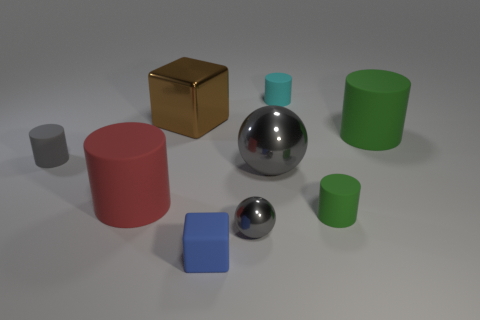The rubber cylinder that is the same color as the small shiny sphere is what size?
Offer a very short reply. Small. Is the brown metallic thing the same size as the cyan thing?
Make the answer very short. No. The gray object that is the same shape as the tiny green matte object is what size?
Your answer should be very brief. Small. There is a green thing behind the gray cylinder; does it have the same size as the block in front of the small gray cylinder?
Keep it short and to the point. No. Do the cyan object and the small gray thing that is to the right of the big red rubber object have the same material?
Ensure brevity in your answer.  No. How many blue things are large cylinders or shiny balls?
Your response must be concise. 0. Are there any blue balls that have the same size as the cyan object?
Make the answer very short. No. The gray thing left of the small cube in front of the green object behind the red cylinder is made of what material?
Offer a very short reply. Rubber. Are there the same number of large metal spheres that are to the right of the small cyan matte cylinder and small blue shiny blocks?
Offer a terse response. Yes. Is the gray thing left of the blue block made of the same material as the tiny cylinder in front of the big gray shiny sphere?
Your answer should be compact. Yes. 